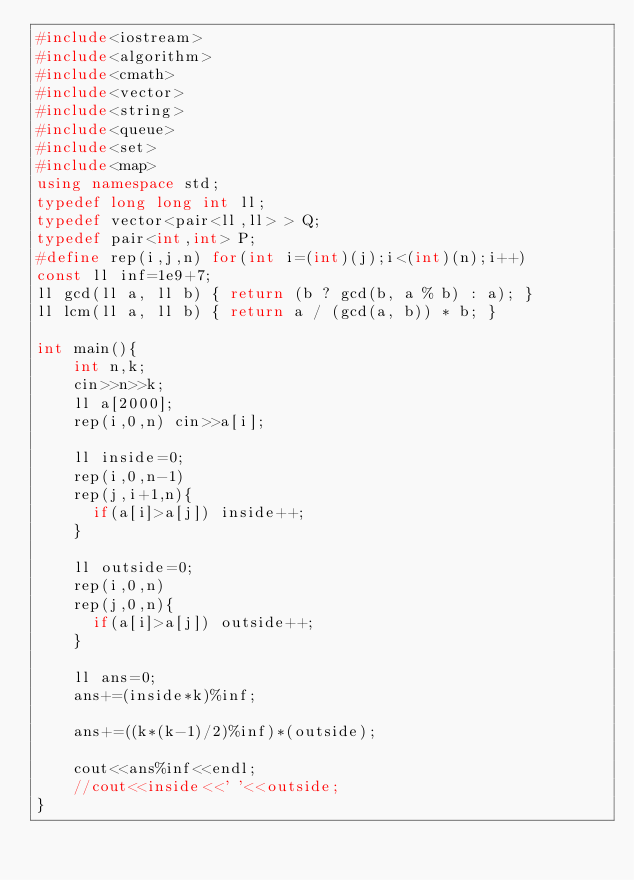<code> <loc_0><loc_0><loc_500><loc_500><_C++_>#include<iostream>
#include<algorithm>
#include<cmath>
#include<vector>
#include<string>
#include<queue>
#include<set>
#include<map>
using namespace std;
typedef long long int ll;
typedef vector<pair<ll,ll> > Q;
typedef pair<int,int> P;
#define rep(i,j,n) for(int i=(int)(j);i<(int)(n);i++)
const ll inf=1e9+7;
ll gcd(ll a, ll b) { return (b ? gcd(b, a % b) : a); }
ll lcm(ll a, ll b) { return a / (gcd(a, b)) * b; }

int main(){
    int n,k;
    cin>>n>>k;
    ll a[2000];
    rep(i,0,n) cin>>a[i];

    ll inside=0;
    rep(i,0,n-1)
    rep(j,i+1,n){
      if(a[i]>a[j]) inside++;
    }

    ll outside=0;
    rep(i,0,n)
    rep(j,0,n){
      if(a[i]>a[j]) outside++;
    }

    ll ans=0;
    ans+=(inside*k)%inf;

    ans+=((k*(k-1)/2)%inf)*(outside);

    cout<<ans%inf<<endl;
    //cout<<inside<<' '<<outside;
}
</code> 